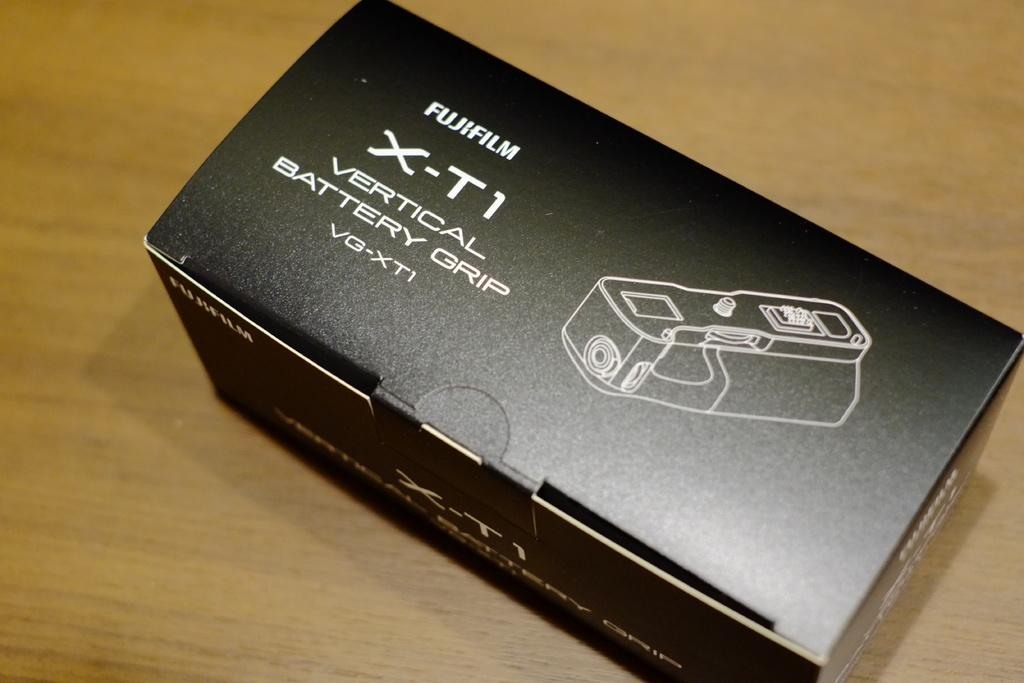<image>
Describe the image concisely. a box that has a fujifulm x-t1 battery grip 